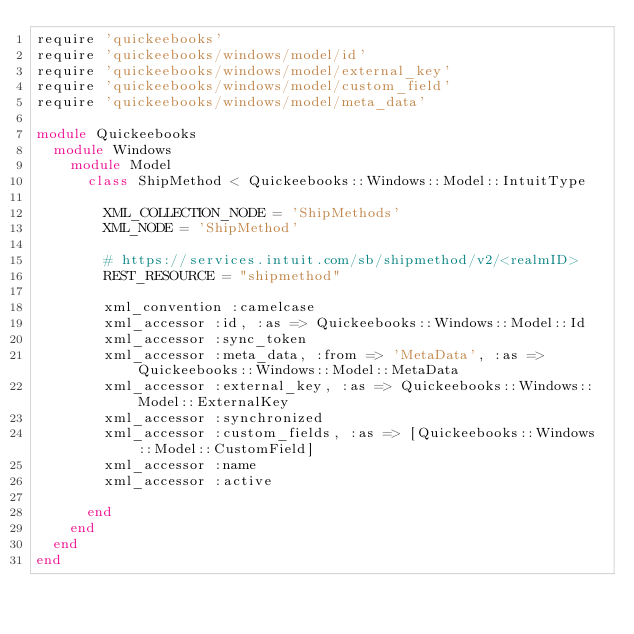<code> <loc_0><loc_0><loc_500><loc_500><_Ruby_>require 'quickeebooks'
require 'quickeebooks/windows/model/id'
require 'quickeebooks/windows/model/external_key'
require 'quickeebooks/windows/model/custom_field'
require 'quickeebooks/windows/model/meta_data'

module Quickeebooks
  module Windows
    module Model
      class ShipMethod < Quickeebooks::Windows::Model::IntuitType

        XML_COLLECTION_NODE = 'ShipMethods'
        XML_NODE = 'ShipMethod'
        
        # https://services.intuit.com/sb/shipmethod/v2/<realmID>
        REST_RESOURCE = "shipmethod"
        
        xml_convention :camelcase
        xml_accessor :id, :as => Quickeebooks::Windows::Model::Id
        xml_accessor :sync_token
        xml_accessor :meta_data, :from => 'MetaData', :as => Quickeebooks::Windows::Model::MetaData
        xml_accessor :external_key, :as => Quickeebooks::Windows::Model::ExternalKey
        xml_accessor :synchronized
        xml_accessor :custom_fields, :as => [Quickeebooks::Windows::Model::CustomField]
        xml_accessor :name
        xml_accessor :active

      end
    end
  end
end</code> 